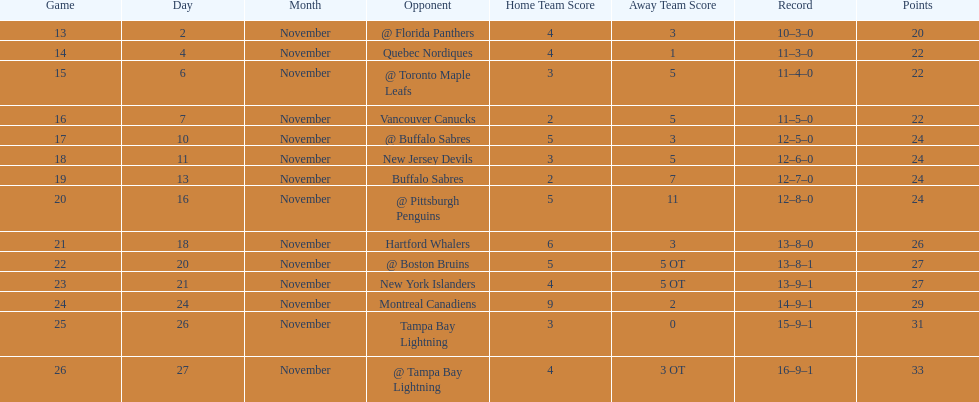What was the number of wins the philadelphia flyers had? 35. 